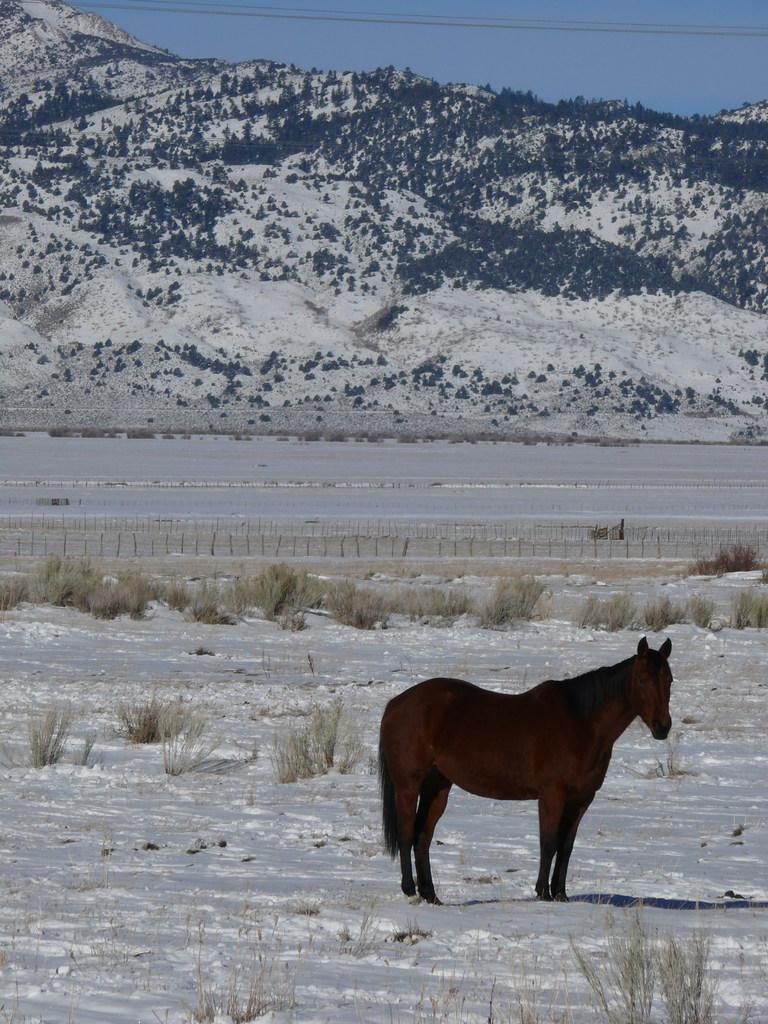Can you describe this image briefly? At the bottom of this image, there is a brown color horse on a snow surface of a ground, on which there is grass. In the background, there are mountains, cables and the blue sky. 